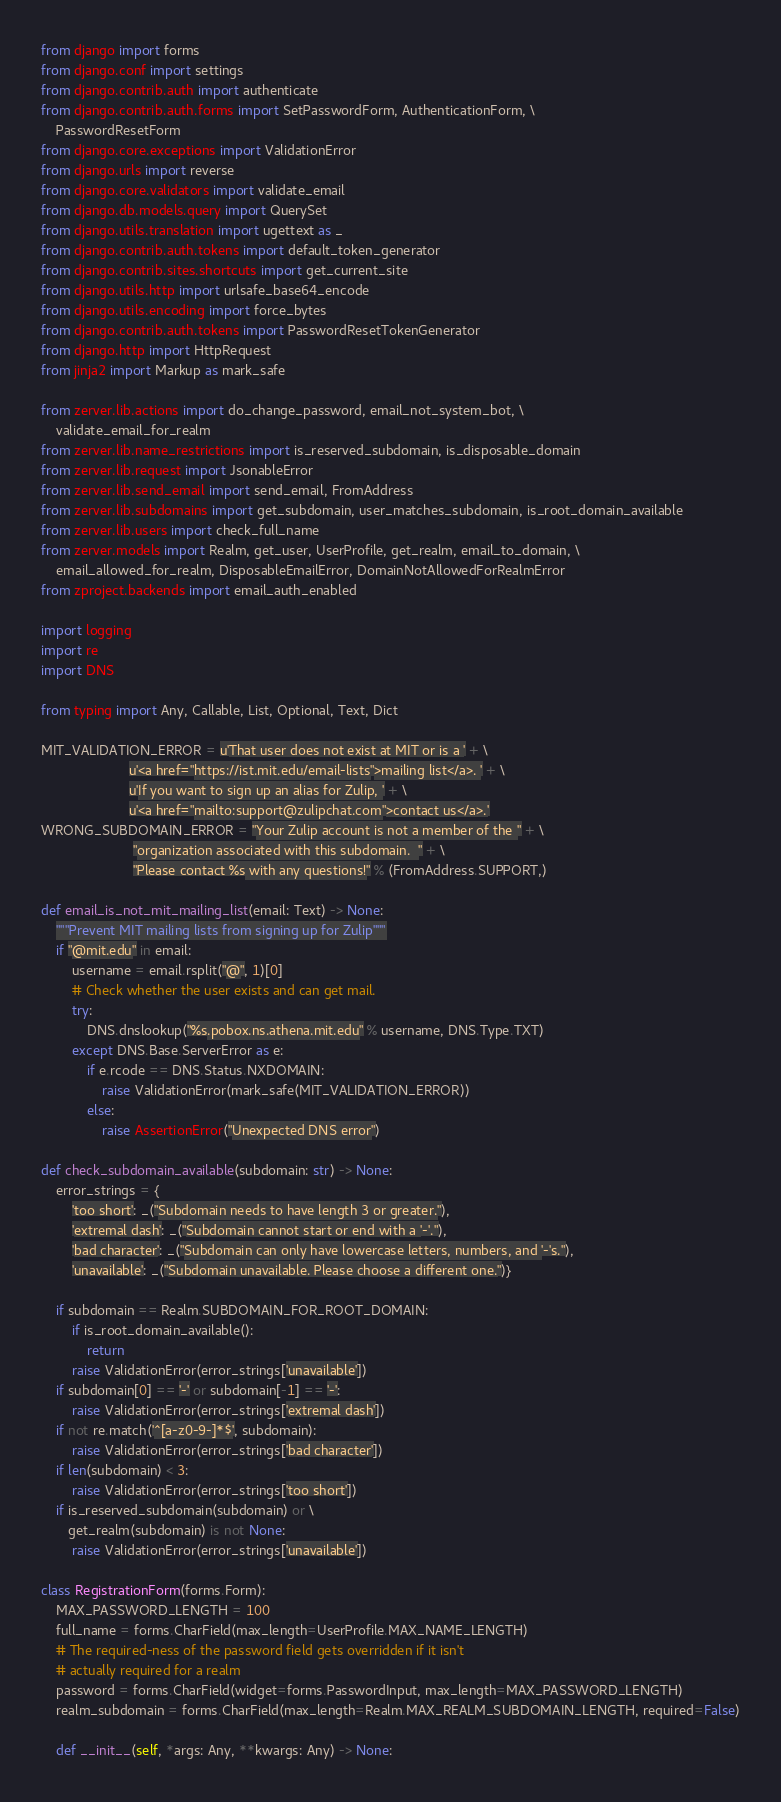<code> <loc_0><loc_0><loc_500><loc_500><_Python_>
from django import forms
from django.conf import settings
from django.contrib.auth import authenticate
from django.contrib.auth.forms import SetPasswordForm, AuthenticationForm, \
    PasswordResetForm
from django.core.exceptions import ValidationError
from django.urls import reverse
from django.core.validators import validate_email
from django.db.models.query import QuerySet
from django.utils.translation import ugettext as _
from django.contrib.auth.tokens import default_token_generator
from django.contrib.sites.shortcuts import get_current_site
from django.utils.http import urlsafe_base64_encode
from django.utils.encoding import force_bytes
from django.contrib.auth.tokens import PasswordResetTokenGenerator
from django.http import HttpRequest
from jinja2 import Markup as mark_safe

from zerver.lib.actions import do_change_password, email_not_system_bot, \
    validate_email_for_realm
from zerver.lib.name_restrictions import is_reserved_subdomain, is_disposable_domain
from zerver.lib.request import JsonableError
from zerver.lib.send_email import send_email, FromAddress
from zerver.lib.subdomains import get_subdomain, user_matches_subdomain, is_root_domain_available
from zerver.lib.users import check_full_name
from zerver.models import Realm, get_user, UserProfile, get_realm, email_to_domain, \
    email_allowed_for_realm, DisposableEmailError, DomainNotAllowedForRealmError
from zproject.backends import email_auth_enabled

import logging
import re
import DNS

from typing import Any, Callable, List, Optional, Text, Dict

MIT_VALIDATION_ERROR = u'That user does not exist at MIT or is a ' + \
                       u'<a href="https://ist.mit.edu/email-lists">mailing list</a>. ' + \
                       u'If you want to sign up an alias for Zulip, ' + \
                       u'<a href="mailto:support@zulipchat.com">contact us</a>.'
WRONG_SUBDOMAIN_ERROR = "Your Zulip account is not a member of the " + \
                        "organization associated with this subdomain.  " + \
                        "Please contact %s with any questions!" % (FromAddress.SUPPORT,)

def email_is_not_mit_mailing_list(email: Text) -> None:
    """Prevent MIT mailing lists from signing up for Zulip"""
    if "@mit.edu" in email:
        username = email.rsplit("@", 1)[0]
        # Check whether the user exists and can get mail.
        try:
            DNS.dnslookup("%s.pobox.ns.athena.mit.edu" % username, DNS.Type.TXT)
        except DNS.Base.ServerError as e:
            if e.rcode == DNS.Status.NXDOMAIN:
                raise ValidationError(mark_safe(MIT_VALIDATION_ERROR))
            else:
                raise AssertionError("Unexpected DNS error")

def check_subdomain_available(subdomain: str) -> None:
    error_strings = {
        'too short': _("Subdomain needs to have length 3 or greater."),
        'extremal dash': _("Subdomain cannot start or end with a '-'."),
        'bad character': _("Subdomain can only have lowercase letters, numbers, and '-'s."),
        'unavailable': _("Subdomain unavailable. Please choose a different one.")}

    if subdomain == Realm.SUBDOMAIN_FOR_ROOT_DOMAIN:
        if is_root_domain_available():
            return
        raise ValidationError(error_strings['unavailable'])
    if subdomain[0] == '-' or subdomain[-1] == '-':
        raise ValidationError(error_strings['extremal dash'])
    if not re.match('^[a-z0-9-]*$', subdomain):
        raise ValidationError(error_strings['bad character'])
    if len(subdomain) < 3:
        raise ValidationError(error_strings['too short'])
    if is_reserved_subdomain(subdomain) or \
       get_realm(subdomain) is not None:
        raise ValidationError(error_strings['unavailable'])

class RegistrationForm(forms.Form):
    MAX_PASSWORD_LENGTH = 100
    full_name = forms.CharField(max_length=UserProfile.MAX_NAME_LENGTH)
    # The required-ness of the password field gets overridden if it isn't
    # actually required for a realm
    password = forms.CharField(widget=forms.PasswordInput, max_length=MAX_PASSWORD_LENGTH)
    realm_subdomain = forms.CharField(max_length=Realm.MAX_REALM_SUBDOMAIN_LENGTH, required=False)

    def __init__(self, *args: Any, **kwargs: Any) -> None:</code> 